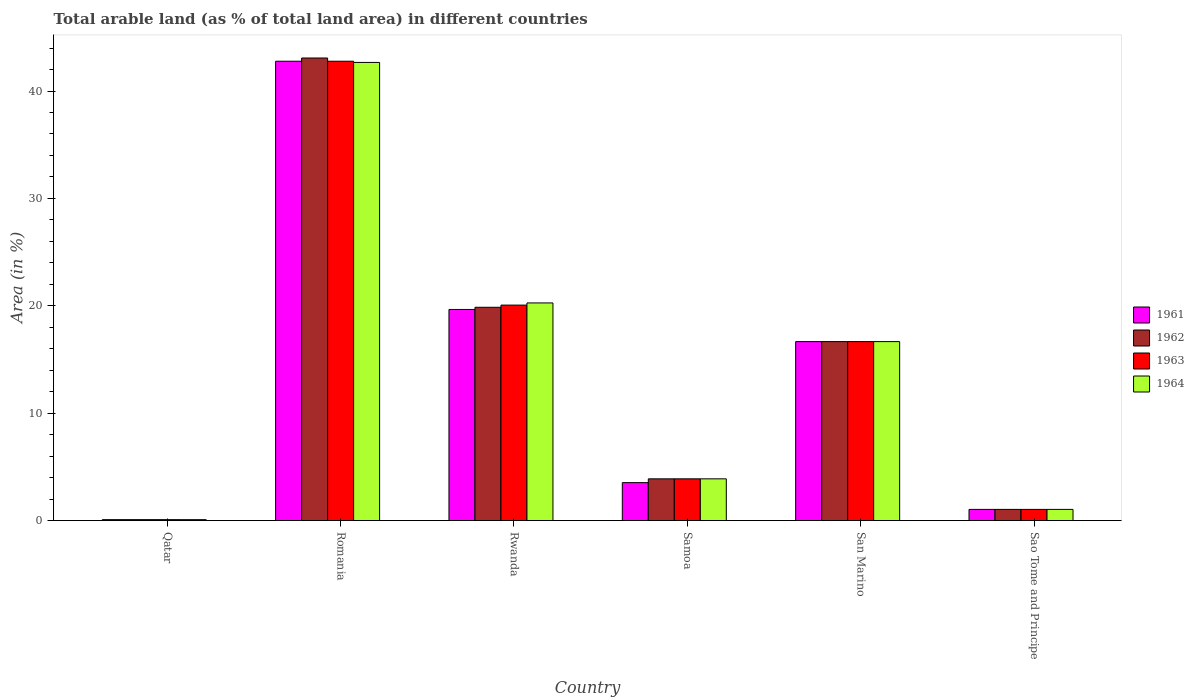How many different coloured bars are there?
Ensure brevity in your answer.  4. How many groups of bars are there?
Your response must be concise. 6. Are the number of bars per tick equal to the number of legend labels?
Make the answer very short. Yes. What is the label of the 2nd group of bars from the left?
Your response must be concise. Romania. In how many cases, is the number of bars for a given country not equal to the number of legend labels?
Make the answer very short. 0. What is the percentage of arable land in 1962 in Qatar?
Your answer should be very brief. 0.09. Across all countries, what is the maximum percentage of arable land in 1963?
Your response must be concise. 42.78. Across all countries, what is the minimum percentage of arable land in 1964?
Make the answer very short. 0.09. In which country was the percentage of arable land in 1963 maximum?
Provide a succinct answer. Romania. In which country was the percentage of arable land in 1964 minimum?
Keep it short and to the point. Qatar. What is the total percentage of arable land in 1961 in the graph?
Ensure brevity in your answer.  83.76. What is the difference between the percentage of arable land in 1962 in Qatar and that in Romania?
Ensure brevity in your answer.  -42.99. What is the difference between the percentage of arable land in 1962 in San Marino and the percentage of arable land in 1964 in Sao Tome and Principe?
Provide a short and direct response. 15.63. What is the average percentage of arable land in 1961 per country?
Give a very brief answer. 13.96. What is the difference between the percentage of arable land of/in 1964 and percentage of arable land of/in 1963 in Romania?
Keep it short and to the point. -0.11. What is the ratio of the percentage of arable land in 1963 in Rwanda to that in San Marino?
Provide a short and direct response. 1.2. Is the percentage of arable land in 1963 in Qatar less than that in Samoa?
Your answer should be compact. Yes. Is the difference between the percentage of arable land in 1964 in San Marino and Sao Tome and Principe greater than the difference between the percentage of arable land in 1963 in San Marino and Sao Tome and Principe?
Your response must be concise. No. What is the difference between the highest and the second highest percentage of arable land in 1961?
Your response must be concise. -26.11. What is the difference between the highest and the lowest percentage of arable land in 1964?
Offer a terse response. 42.58. Is the sum of the percentage of arable land in 1961 in Rwanda and San Marino greater than the maximum percentage of arable land in 1964 across all countries?
Give a very brief answer. No. What does the 1st bar from the left in Romania represents?
Provide a short and direct response. 1961. What does the 4th bar from the right in Qatar represents?
Offer a terse response. 1961. How many bars are there?
Your response must be concise. 24. How many countries are there in the graph?
Give a very brief answer. 6. Where does the legend appear in the graph?
Your response must be concise. Center right. How are the legend labels stacked?
Your response must be concise. Vertical. What is the title of the graph?
Offer a very short reply. Total arable land (as % of total land area) in different countries. Does "1981" appear as one of the legend labels in the graph?
Your answer should be compact. No. What is the label or title of the Y-axis?
Ensure brevity in your answer.  Area (in %). What is the Area (in %) of 1961 in Qatar?
Your response must be concise. 0.09. What is the Area (in %) of 1962 in Qatar?
Provide a short and direct response. 0.09. What is the Area (in %) in 1963 in Qatar?
Ensure brevity in your answer.  0.09. What is the Area (in %) of 1964 in Qatar?
Provide a succinct answer. 0.09. What is the Area (in %) of 1961 in Romania?
Provide a succinct answer. 42.78. What is the Area (in %) in 1962 in Romania?
Your answer should be compact. 43.08. What is the Area (in %) in 1963 in Romania?
Make the answer very short. 42.78. What is the Area (in %) of 1964 in Romania?
Provide a succinct answer. 42.66. What is the Area (in %) in 1961 in Rwanda?
Offer a terse response. 19.66. What is the Area (in %) of 1962 in Rwanda?
Offer a terse response. 19.86. What is the Area (in %) in 1963 in Rwanda?
Offer a terse response. 20.06. What is the Area (in %) of 1964 in Rwanda?
Give a very brief answer. 20.27. What is the Area (in %) of 1961 in Samoa?
Your answer should be compact. 3.53. What is the Area (in %) of 1962 in Samoa?
Give a very brief answer. 3.89. What is the Area (in %) of 1963 in Samoa?
Give a very brief answer. 3.89. What is the Area (in %) of 1964 in Samoa?
Your answer should be very brief. 3.89. What is the Area (in %) of 1961 in San Marino?
Give a very brief answer. 16.67. What is the Area (in %) in 1962 in San Marino?
Your answer should be very brief. 16.67. What is the Area (in %) of 1963 in San Marino?
Make the answer very short. 16.67. What is the Area (in %) of 1964 in San Marino?
Ensure brevity in your answer.  16.67. What is the Area (in %) of 1961 in Sao Tome and Principe?
Provide a succinct answer. 1.04. What is the Area (in %) of 1962 in Sao Tome and Principe?
Keep it short and to the point. 1.04. What is the Area (in %) of 1963 in Sao Tome and Principe?
Give a very brief answer. 1.04. What is the Area (in %) of 1964 in Sao Tome and Principe?
Your answer should be compact. 1.04. Across all countries, what is the maximum Area (in %) in 1961?
Ensure brevity in your answer.  42.78. Across all countries, what is the maximum Area (in %) of 1962?
Your response must be concise. 43.08. Across all countries, what is the maximum Area (in %) in 1963?
Make the answer very short. 42.78. Across all countries, what is the maximum Area (in %) in 1964?
Your answer should be compact. 42.66. Across all countries, what is the minimum Area (in %) of 1961?
Give a very brief answer. 0.09. Across all countries, what is the minimum Area (in %) of 1962?
Keep it short and to the point. 0.09. Across all countries, what is the minimum Area (in %) of 1963?
Your answer should be compact. 0.09. Across all countries, what is the minimum Area (in %) in 1964?
Provide a short and direct response. 0.09. What is the total Area (in %) in 1961 in the graph?
Your response must be concise. 83.76. What is the total Area (in %) in 1962 in the graph?
Offer a terse response. 84.62. What is the total Area (in %) in 1963 in the graph?
Your response must be concise. 84.52. What is the total Area (in %) of 1964 in the graph?
Provide a succinct answer. 84.61. What is the difference between the Area (in %) of 1961 in Qatar and that in Romania?
Your answer should be compact. -42.69. What is the difference between the Area (in %) of 1962 in Qatar and that in Romania?
Provide a short and direct response. -42.99. What is the difference between the Area (in %) of 1963 in Qatar and that in Romania?
Your response must be concise. -42.69. What is the difference between the Area (in %) in 1964 in Qatar and that in Romania?
Make the answer very short. -42.58. What is the difference between the Area (in %) of 1961 in Qatar and that in Rwanda?
Give a very brief answer. -19.57. What is the difference between the Area (in %) of 1962 in Qatar and that in Rwanda?
Provide a succinct answer. -19.78. What is the difference between the Area (in %) of 1963 in Qatar and that in Rwanda?
Offer a terse response. -19.98. What is the difference between the Area (in %) of 1964 in Qatar and that in Rwanda?
Offer a very short reply. -20.18. What is the difference between the Area (in %) in 1961 in Qatar and that in Samoa?
Ensure brevity in your answer.  -3.45. What is the difference between the Area (in %) of 1962 in Qatar and that in Samoa?
Your response must be concise. -3.8. What is the difference between the Area (in %) in 1963 in Qatar and that in Samoa?
Offer a very short reply. -3.8. What is the difference between the Area (in %) of 1964 in Qatar and that in Samoa?
Provide a short and direct response. -3.8. What is the difference between the Area (in %) of 1961 in Qatar and that in San Marino?
Make the answer very short. -16.58. What is the difference between the Area (in %) in 1962 in Qatar and that in San Marino?
Your answer should be compact. -16.58. What is the difference between the Area (in %) in 1963 in Qatar and that in San Marino?
Make the answer very short. -16.58. What is the difference between the Area (in %) of 1964 in Qatar and that in San Marino?
Give a very brief answer. -16.58. What is the difference between the Area (in %) of 1961 in Qatar and that in Sao Tome and Principe?
Make the answer very short. -0.96. What is the difference between the Area (in %) in 1962 in Qatar and that in Sao Tome and Principe?
Ensure brevity in your answer.  -0.96. What is the difference between the Area (in %) of 1963 in Qatar and that in Sao Tome and Principe?
Keep it short and to the point. -0.96. What is the difference between the Area (in %) of 1964 in Qatar and that in Sao Tome and Principe?
Your answer should be very brief. -0.96. What is the difference between the Area (in %) in 1961 in Romania and that in Rwanda?
Keep it short and to the point. 23.12. What is the difference between the Area (in %) in 1962 in Romania and that in Rwanda?
Your answer should be compact. 23.21. What is the difference between the Area (in %) of 1963 in Romania and that in Rwanda?
Offer a very short reply. 22.71. What is the difference between the Area (in %) in 1964 in Romania and that in Rwanda?
Keep it short and to the point. 22.4. What is the difference between the Area (in %) in 1961 in Romania and that in Samoa?
Your response must be concise. 39.24. What is the difference between the Area (in %) in 1962 in Romania and that in Samoa?
Ensure brevity in your answer.  39.19. What is the difference between the Area (in %) of 1963 in Romania and that in Samoa?
Offer a terse response. 38.89. What is the difference between the Area (in %) in 1964 in Romania and that in Samoa?
Offer a terse response. 38.78. What is the difference between the Area (in %) of 1961 in Romania and that in San Marino?
Your response must be concise. 26.11. What is the difference between the Area (in %) of 1962 in Romania and that in San Marino?
Your response must be concise. 26.41. What is the difference between the Area (in %) of 1963 in Romania and that in San Marino?
Give a very brief answer. 26.11. What is the difference between the Area (in %) of 1964 in Romania and that in San Marino?
Give a very brief answer. 26. What is the difference between the Area (in %) of 1961 in Romania and that in Sao Tome and Principe?
Offer a terse response. 41.73. What is the difference between the Area (in %) of 1962 in Romania and that in Sao Tome and Principe?
Give a very brief answer. 42.03. What is the difference between the Area (in %) of 1963 in Romania and that in Sao Tome and Principe?
Offer a terse response. 41.73. What is the difference between the Area (in %) in 1964 in Romania and that in Sao Tome and Principe?
Your response must be concise. 41.62. What is the difference between the Area (in %) in 1961 in Rwanda and that in Samoa?
Offer a very short reply. 16.13. What is the difference between the Area (in %) in 1962 in Rwanda and that in Samoa?
Give a very brief answer. 15.98. What is the difference between the Area (in %) in 1963 in Rwanda and that in Samoa?
Your answer should be very brief. 16.18. What is the difference between the Area (in %) in 1964 in Rwanda and that in Samoa?
Ensure brevity in your answer.  16.38. What is the difference between the Area (in %) of 1961 in Rwanda and that in San Marino?
Your answer should be very brief. 2.99. What is the difference between the Area (in %) in 1962 in Rwanda and that in San Marino?
Give a very brief answer. 3.2. What is the difference between the Area (in %) of 1963 in Rwanda and that in San Marino?
Provide a short and direct response. 3.4. What is the difference between the Area (in %) of 1964 in Rwanda and that in San Marino?
Your answer should be compact. 3.6. What is the difference between the Area (in %) in 1961 in Rwanda and that in Sao Tome and Principe?
Make the answer very short. 18.62. What is the difference between the Area (in %) in 1962 in Rwanda and that in Sao Tome and Principe?
Ensure brevity in your answer.  18.82. What is the difference between the Area (in %) in 1963 in Rwanda and that in Sao Tome and Principe?
Offer a terse response. 19.02. What is the difference between the Area (in %) in 1964 in Rwanda and that in Sao Tome and Principe?
Ensure brevity in your answer.  19.23. What is the difference between the Area (in %) in 1961 in Samoa and that in San Marino?
Your answer should be very brief. -13.13. What is the difference between the Area (in %) of 1962 in Samoa and that in San Marino?
Your answer should be compact. -12.78. What is the difference between the Area (in %) of 1963 in Samoa and that in San Marino?
Give a very brief answer. -12.78. What is the difference between the Area (in %) in 1964 in Samoa and that in San Marino?
Give a very brief answer. -12.78. What is the difference between the Area (in %) in 1961 in Samoa and that in Sao Tome and Principe?
Provide a short and direct response. 2.49. What is the difference between the Area (in %) in 1962 in Samoa and that in Sao Tome and Principe?
Keep it short and to the point. 2.85. What is the difference between the Area (in %) of 1963 in Samoa and that in Sao Tome and Principe?
Your answer should be very brief. 2.85. What is the difference between the Area (in %) of 1964 in Samoa and that in Sao Tome and Principe?
Offer a very short reply. 2.85. What is the difference between the Area (in %) in 1961 in San Marino and that in Sao Tome and Principe?
Provide a succinct answer. 15.62. What is the difference between the Area (in %) in 1962 in San Marino and that in Sao Tome and Principe?
Keep it short and to the point. 15.62. What is the difference between the Area (in %) of 1963 in San Marino and that in Sao Tome and Principe?
Your answer should be compact. 15.62. What is the difference between the Area (in %) in 1964 in San Marino and that in Sao Tome and Principe?
Your response must be concise. 15.62. What is the difference between the Area (in %) of 1961 in Qatar and the Area (in %) of 1962 in Romania?
Give a very brief answer. -42.99. What is the difference between the Area (in %) in 1961 in Qatar and the Area (in %) in 1963 in Romania?
Give a very brief answer. -42.69. What is the difference between the Area (in %) in 1961 in Qatar and the Area (in %) in 1964 in Romania?
Offer a terse response. -42.58. What is the difference between the Area (in %) of 1962 in Qatar and the Area (in %) of 1963 in Romania?
Offer a very short reply. -42.69. What is the difference between the Area (in %) in 1962 in Qatar and the Area (in %) in 1964 in Romania?
Ensure brevity in your answer.  -42.58. What is the difference between the Area (in %) of 1963 in Qatar and the Area (in %) of 1964 in Romania?
Keep it short and to the point. -42.58. What is the difference between the Area (in %) in 1961 in Qatar and the Area (in %) in 1962 in Rwanda?
Your response must be concise. -19.78. What is the difference between the Area (in %) in 1961 in Qatar and the Area (in %) in 1963 in Rwanda?
Make the answer very short. -19.98. What is the difference between the Area (in %) in 1961 in Qatar and the Area (in %) in 1964 in Rwanda?
Make the answer very short. -20.18. What is the difference between the Area (in %) of 1962 in Qatar and the Area (in %) of 1963 in Rwanda?
Provide a short and direct response. -19.98. What is the difference between the Area (in %) of 1962 in Qatar and the Area (in %) of 1964 in Rwanda?
Keep it short and to the point. -20.18. What is the difference between the Area (in %) of 1963 in Qatar and the Area (in %) of 1964 in Rwanda?
Your answer should be compact. -20.18. What is the difference between the Area (in %) of 1961 in Qatar and the Area (in %) of 1962 in Samoa?
Provide a succinct answer. -3.8. What is the difference between the Area (in %) in 1961 in Qatar and the Area (in %) in 1963 in Samoa?
Your answer should be very brief. -3.8. What is the difference between the Area (in %) of 1961 in Qatar and the Area (in %) of 1964 in Samoa?
Your answer should be very brief. -3.8. What is the difference between the Area (in %) of 1962 in Qatar and the Area (in %) of 1963 in Samoa?
Give a very brief answer. -3.8. What is the difference between the Area (in %) of 1962 in Qatar and the Area (in %) of 1964 in Samoa?
Offer a very short reply. -3.8. What is the difference between the Area (in %) in 1963 in Qatar and the Area (in %) in 1964 in Samoa?
Make the answer very short. -3.8. What is the difference between the Area (in %) of 1961 in Qatar and the Area (in %) of 1962 in San Marino?
Ensure brevity in your answer.  -16.58. What is the difference between the Area (in %) of 1961 in Qatar and the Area (in %) of 1963 in San Marino?
Your answer should be very brief. -16.58. What is the difference between the Area (in %) of 1961 in Qatar and the Area (in %) of 1964 in San Marino?
Offer a very short reply. -16.58. What is the difference between the Area (in %) in 1962 in Qatar and the Area (in %) in 1963 in San Marino?
Give a very brief answer. -16.58. What is the difference between the Area (in %) of 1962 in Qatar and the Area (in %) of 1964 in San Marino?
Your response must be concise. -16.58. What is the difference between the Area (in %) of 1963 in Qatar and the Area (in %) of 1964 in San Marino?
Ensure brevity in your answer.  -16.58. What is the difference between the Area (in %) of 1961 in Qatar and the Area (in %) of 1962 in Sao Tome and Principe?
Provide a succinct answer. -0.96. What is the difference between the Area (in %) in 1961 in Qatar and the Area (in %) in 1963 in Sao Tome and Principe?
Keep it short and to the point. -0.96. What is the difference between the Area (in %) of 1961 in Qatar and the Area (in %) of 1964 in Sao Tome and Principe?
Provide a short and direct response. -0.96. What is the difference between the Area (in %) in 1962 in Qatar and the Area (in %) in 1963 in Sao Tome and Principe?
Provide a succinct answer. -0.96. What is the difference between the Area (in %) in 1962 in Qatar and the Area (in %) in 1964 in Sao Tome and Principe?
Your answer should be compact. -0.96. What is the difference between the Area (in %) in 1963 in Qatar and the Area (in %) in 1964 in Sao Tome and Principe?
Offer a terse response. -0.96. What is the difference between the Area (in %) in 1961 in Romania and the Area (in %) in 1962 in Rwanda?
Keep it short and to the point. 22.91. What is the difference between the Area (in %) in 1961 in Romania and the Area (in %) in 1963 in Rwanda?
Give a very brief answer. 22.71. What is the difference between the Area (in %) of 1961 in Romania and the Area (in %) of 1964 in Rwanda?
Offer a terse response. 22.51. What is the difference between the Area (in %) of 1962 in Romania and the Area (in %) of 1963 in Rwanda?
Your answer should be compact. 23.01. What is the difference between the Area (in %) of 1962 in Romania and the Area (in %) of 1964 in Rwanda?
Provide a short and direct response. 22.81. What is the difference between the Area (in %) in 1963 in Romania and the Area (in %) in 1964 in Rwanda?
Provide a short and direct response. 22.51. What is the difference between the Area (in %) of 1961 in Romania and the Area (in %) of 1962 in Samoa?
Ensure brevity in your answer.  38.89. What is the difference between the Area (in %) of 1961 in Romania and the Area (in %) of 1963 in Samoa?
Ensure brevity in your answer.  38.89. What is the difference between the Area (in %) of 1961 in Romania and the Area (in %) of 1964 in Samoa?
Your response must be concise. 38.89. What is the difference between the Area (in %) of 1962 in Romania and the Area (in %) of 1963 in Samoa?
Make the answer very short. 39.19. What is the difference between the Area (in %) in 1962 in Romania and the Area (in %) in 1964 in Samoa?
Your answer should be compact. 39.19. What is the difference between the Area (in %) of 1963 in Romania and the Area (in %) of 1964 in Samoa?
Your response must be concise. 38.89. What is the difference between the Area (in %) of 1961 in Romania and the Area (in %) of 1962 in San Marino?
Your answer should be compact. 26.11. What is the difference between the Area (in %) of 1961 in Romania and the Area (in %) of 1963 in San Marino?
Ensure brevity in your answer.  26.11. What is the difference between the Area (in %) of 1961 in Romania and the Area (in %) of 1964 in San Marino?
Your response must be concise. 26.11. What is the difference between the Area (in %) in 1962 in Romania and the Area (in %) in 1963 in San Marino?
Give a very brief answer. 26.41. What is the difference between the Area (in %) in 1962 in Romania and the Area (in %) in 1964 in San Marino?
Make the answer very short. 26.41. What is the difference between the Area (in %) in 1963 in Romania and the Area (in %) in 1964 in San Marino?
Offer a very short reply. 26.11. What is the difference between the Area (in %) of 1961 in Romania and the Area (in %) of 1962 in Sao Tome and Principe?
Make the answer very short. 41.73. What is the difference between the Area (in %) of 1961 in Romania and the Area (in %) of 1963 in Sao Tome and Principe?
Make the answer very short. 41.73. What is the difference between the Area (in %) in 1961 in Romania and the Area (in %) in 1964 in Sao Tome and Principe?
Provide a short and direct response. 41.73. What is the difference between the Area (in %) in 1962 in Romania and the Area (in %) in 1963 in Sao Tome and Principe?
Keep it short and to the point. 42.03. What is the difference between the Area (in %) of 1962 in Romania and the Area (in %) of 1964 in Sao Tome and Principe?
Ensure brevity in your answer.  42.03. What is the difference between the Area (in %) of 1963 in Romania and the Area (in %) of 1964 in Sao Tome and Principe?
Offer a terse response. 41.73. What is the difference between the Area (in %) of 1961 in Rwanda and the Area (in %) of 1962 in Samoa?
Your answer should be compact. 15.77. What is the difference between the Area (in %) in 1961 in Rwanda and the Area (in %) in 1963 in Samoa?
Offer a very short reply. 15.77. What is the difference between the Area (in %) of 1961 in Rwanda and the Area (in %) of 1964 in Samoa?
Offer a terse response. 15.77. What is the difference between the Area (in %) in 1962 in Rwanda and the Area (in %) in 1963 in Samoa?
Keep it short and to the point. 15.98. What is the difference between the Area (in %) in 1962 in Rwanda and the Area (in %) in 1964 in Samoa?
Your response must be concise. 15.98. What is the difference between the Area (in %) of 1963 in Rwanda and the Area (in %) of 1964 in Samoa?
Give a very brief answer. 16.18. What is the difference between the Area (in %) of 1961 in Rwanda and the Area (in %) of 1962 in San Marino?
Your answer should be compact. 2.99. What is the difference between the Area (in %) in 1961 in Rwanda and the Area (in %) in 1963 in San Marino?
Provide a short and direct response. 2.99. What is the difference between the Area (in %) of 1961 in Rwanda and the Area (in %) of 1964 in San Marino?
Your answer should be very brief. 2.99. What is the difference between the Area (in %) of 1962 in Rwanda and the Area (in %) of 1963 in San Marino?
Ensure brevity in your answer.  3.2. What is the difference between the Area (in %) of 1962 in Rwanda and the Area (in %) of 1964 in San Marino?
Make the answer very short. 3.2. What is the difference between the Area (in %) in 1963 in Rwanda and the Area (in %) in 1964 in San Marino?
Your response must be concise. 3.4. What is the difference between the Area (in %) of 1961 in Rwanda and the Area (in %) of 1962 in Sao Tome and Principe?
Keep it short and to the point. 18.62. What is the difference between the Area (in %) in 1961 in Rwanda and the Area (in %) in 1963 in Sao Tome and Principe?
Make the answer very short. 18.62. What is the difference between the Area (in %) of 1961 in Rwanda and the Area (in %) of 1964 in Sao Tome and Principe?
Your response must be concise. 18.62. What is the difference between the Area (in %) in 1962 in Rwanda and the Area (in %) in 1963 in Sao Tome and Principe?
Provide a short and direct response. 18.82. What is the difference between the Area (in %) in 1962 in Rwanda and the Area (in %) in 1964 in Sao Tome and Principe?
Offer a terse response. 18.82. What is the difference between the Area (in %) of 1963 in Rwanda and the Area (in %) of 1964 in Sao Tome and Principe?
Ensure brevity in your answer.  19.02. What is the difference between the Area (in %) in 1961 in Samoa and the Area (in %) in 1962 in San Marino?
Provide a succinct answer. -13.13. What is the difference between the Area (in %) in 1961 in Samoa and the Area (in %) in 1963 in San Marino?
Provide a short and direct response. -13.13. What is the difference between the Area (in %) of 1961 in Samoa and the Area (in %) of 1964 in San Marino?
Provide a succinct answer. -13.13. What is the difference between the Area (in %) of 1962 in Samoa and the Area (in %) of 1963 in San Marino?
Ensure brevity in your answer.  -12.78. What is the difference between the Area (in %) in 1962 in Samoa and the Area (in %) in 1964 in San Marino?
Provide a succinct answer. -12.78. What is the difference between the Area (in %) in 1963 in Samoa and the Area (in %) in 1964 in San Marino?
Give a very brief answer. -12.78. What is the difference between the Area (in %) of 1961 in Samoa and the Area (in %) of 1962 in Sao Tome and Principe?
Provide a succinct answer. 2.49. What is the difference between the Area (in %) in 1961 in Samoa and the Area (in %) in 1963 in Sao Tome and Principe?
Offer a very short reply. 2.49. What is the difference between the Area (in %) in 1961 in Samoa and the Area (in %) in 1964 in Sao Tome and Principe?
Offer a terse response. 2.49. What is the difference between the Area (in %) in 1962 in Samoa and the Area (in %) in 1963 in Sao Tome and Principe?
Provide a succinct answer. 2.85. What is the difference between the Area (in %) of 1962 in Samoa and the Area (in %) of 1964 in Sao Tome and Principe?
Offer a terse response. 2.85. What is the difference between the Area (in %) of 1963 in Samoa and the Area (in %) of 1964 in Sao Tome and Principe?
Offer a very short reply. 2.85. What is the difference between the Area (in %) in 1961 in San Marino and the Area (in %) in 1962 in Sao Tome and Principe?
Provide a short and direct response. 15.62. What is the difference between the Area (in %) in 1961 in San Marino and the Area (in %) in 1963 in Sao Tome and Principe?
Your response must be concise. 15.62. What is the difference between the Area (in %) in 1961 in San Marino and the Area (in %) in 1964 in Sao Tome and Principe?
Give a very brief answer. 15.62. What is the difference between the Area (in %) of 1962 in San Marino and the Area (in %) of 1963 in Sao Tome and Principe?
Keep it short and to the point. 15.62. What is the difference between the Area (in %) in 1962 in San Marino and the Area (in %) in 1964 in Sao Tome and Principe?
Offer a terse response. 15.62. What is the difference between the Area (in %) of 1963 in San Marino and the Area (in %) of 1964 in Sao Tome and Principe?
Offer a terse response. 15.62. What is the average Area (in %) in 1961 per country?
Your answer should be very brief. 13.96. What is the average Area (in %) in 1962 per country?
Offer a very short reply. 14.1. What is the average Area (in %) of 1963 per country?
Offer a terse response. 14.09. What is the average Area (in %) in 1964 per country?
Ensure brevity in your answer.  14.1. What is the difference between the Area (in %) of 1961 and Area (in %) of 1964 in Qatar?
Your answer should be compact. 0. What is the difference between the Area (in %) in 1962 and Area (in %) in 1964 in Qatar?
Your answer should be very brief. 0. What is the difference between the Area (in %) in 1961 and Area (in %) in 1962 in Romania?
Your answer should be very brief. -0.3. What is the difference between the Area (in %) in 1961 and Area (in %) in 1964 in Romania?
Your response must be concise. 0.11. What is the difference between the Area (in %) of 1962 and Area (in %) of 1963 in Romania?
Offer a very short reply. 0.3. What is the difference between the Area (in %) of 1962 and Area (in %) of 1964 in Romania?
Make the answer very short. 0.41. What is the difference between the Area (in %) of 1963 and Area (in %) of 1964 in Romania?
Your answer should be compact. 0.11. What is the difference between the Area (in %) in 1961 and Area (in %) in 1962 in Rwanda?
Offer a terse response. -0.2. What is the difference between the Area (in %) of 1961 and Area (in %) of 1963 in Rwanda?
Give a very brief answer. -0.41. What is the difference between the Area (in %) in 1961 and Area (in %) in 1964 in Rwanda?
Your answer should be very brief. -0.61. What is the difference between the Area (in %) in 1962 and Area (in %) in 1963 in Rwanda?
Your answer should be compact. -0.2. What is the difference between the Area (in %) of 1962 and Area (in %) of 1964 in Rwanda?
Ensure brevity in your answer.  -0.41. What is the difference between the Area (in %) of 1963 and Area (in %) of 1964 in Rwanda?
Provide a succinct answer. -0.2. What is the difference between the Area (in %) in 1961 and Area (in %) in 1962 in Samoa?
Your response must be concise. -0.35. What is the difference between the Area (in %) in 1961 and Area (in %) in 1963 in Samoa?
Offer a terse response. -0.35. What is the difference between the Area (in %) of 1961 and Area (in %) of 1964 in Samoa?
Your answer should be compact. -0.35. What is the difference between the Area (in %) in 1962 and Area (in %) in 1964 in Samoa?
Provide a succinct answer. 0. What is the difference between the Area (in %) in 1961 and Area (in %) in 1962 in San Marino?
Offer a terse response. 0. What is the difference between the Area (in %) of 1962 and Area (in %) of 1963 in San Marino?
Provide a succinct answer. 0. What is the difference between the Area (in %) of 1962 and Area (in %) of 1964 in San Marino?
Give a very brief answer. 0. What is the difference between the Area (in %) of 1961 and Area (in %) of 1962 in Sao Tome and Principe?
Ensure brevity in your answer.  0. What is the difference between the Area (in %) in 1961 and Area (in %) in 1963 in Sao Tome and Principe?
Offer a very short reply. 0. What is the difference between the Area (in %) of 1963 and Area (in %) of 1964 in Sao Tome and Principe?
Offer a very short reply. 0. What is the ratio of the Area (in %) in 1961 in Qatar to that in Romania?
Your answer should be very brief. 0. What is the ratio of the Area (in %) of 1962 in Qatar to that in Romania?
Give a very brief answer. 0. What is the ratio of the Area (in %) of 1963 in Qatar to that in Romania?
Your response must be concise. 0. What is the ratio of the Area (in %) of 1964 in Qatar to that in Romania?
Your response must be concise. 0. What is the ratio of the Area (in %) in 1961 in Qatar to that in Rwanda?
Provide a succinct answer. 0. What is the ratio of the Area (in %) of 1962 in Qatar to that in Rwanda?
Offer a terse response. 0. What is the ratio of the Area (in %) in 1963 in Qatar to that in Rwanda?
Your response must be concise. 0. What is the ratio of the Area (in %) in 1964 in Qatar to that in Rwanda?
Provide a short and direct response. 0. What is the ratio of the Area (in %) in 1961 in Qatar to that in Samoa?
Provide a short and direct response. 0.02. What is the ratio of the Area (in %) in 1962 in Qatar to that in Samoa?
Provide a short and direct response. 0.02. What is the ratio of the Area (in %) of 1963 in Qatar to that in Samoa?
Ensure brevity in your answer.  0.02. What is the ratio of the Area (in %) in 1964 in Qatar to that in Samoa?
Offer a terse response. 0.02. What is the ratio of the Area (in %) in 1961 in Qatar to that in San Marino?
Your answer should be very brief. 0.01. What is the ratio of the Area (in %) of 1962 in Qatar to that in San Marino?
Your answer should be very brief. 0.01. What is the ratio of the Area (in %) in 1963 in Qatar to that in San Marino?
Ensure brevity in your answer.  0.01. What is the ratio of the Area (in %) of 1964 in Qatar to that in San Marino?
Provide a short and direct response. 0.01. What is the ratio of the Area (in %) of 1961 in Qatar to that in Sao Tome and Principe?
Provide a short and direct response. 0.08. What is the ratio of the Area (in %) of 1962 in Qatar to that in Sao Tome and Principe?
Keep it short and to the point. 0.08. What is the ratio of the Area (in %) of 1963 in Qatar to that in Sao Tome and Principe?
Offer a very short reply. 0.08. What is the ratio of the Area (in %) in 1964 in Qatar to that in Sao Tome and Principe?
Keep it short and to the point. 0.08. What is the ratio of the Area (in %) in 1961 in Romania to that in Rwanda?
Ensure brevity in your answer.  2.18. What is the ratio of the Area (in %) in 1962 in Romania to that in Rwanda?
Give a very brief answer. 2.17. What is the ratio of the Area (in %) in 1963 in Romania to that in Rwanda?
Give a very brief answer. 2.13. What is the ratio of the Area (in %) in 1964 in Romania to that in Rwanda?
Ensure brevity in your answer.  2.1. What is the ratio of the Area (in %) of 1961 in Romania to that in Samoa?
Offer a very short reply. 12.11. What is the ratio of the Area (in %) of 1962 in Romania to that in Samoa?
Provide a succinct answer. 11.08. What is the ratio of the Area (in %) of 1963 in Romania to that in Samoa?
Offer a terse response. 11.01. What is the ratio of the Area (in %) in 1964 in Romania to that in Samoa?
Your answer should be compact. 10.98. What is the ratio of the Area (in %) in 1961 in Romania to that in San Marino?
Offer a terse response. 2.57. What is the ratio of the Area (in %) in 1962 in Romania to that in San Marino?
Make the answer very short. 2.58. What is the ratio of the Area (in %) of 1963 in Romania to that in San Marino?
Your answer should be very brief. 2.57. What is the ratio of the Area (in %) in 1964 in Romania to that in San Marino?
Keep it short and to the point. 2.56. What is the ratio of the Area (in %) in 1961 in Romania to that in Sao Tome and Principe?
Offer a terse response. 41.06. What is the ratio of the Area (in %) of 1962 in Romania to that in Sao Tome and Principe?
Make the answer very short. 41.35. What is the ratio of the Area (in %) in 1963 in Romania to that in Sao Tome and Principe?
Keep it short and to the point. 41.06. What is the ratio of the Area (in %) in 1964 in Romania to that in Sao Tome and Principe?
Provide a short and direct response. 40.96. What is the ratio of the Area (in %) of 1961 in Rwanda to that in Samoa?
Ensure brevity in your answer.  5.56. What is the ratio of the Area (in %) in 1962 in Rwanda to that in Samoa?
Offer a very short reply. 5.11. What is the ratio of the Area (in %) of 1963 in Rwanda to that in Samoa?
Provide a short and direct response. 5.16. What is the ratio of the Area (in %) in 1964 in Rwanda to that in Samoa?
Your answer should be very brief. 5.21. What is the ratio of the Area (in %) in 1961 in Rwanda to that in San Marino?
Keep it short and to the point. 1.18. What is the ratio of the Area (in %) of 1962 in Rwanda to that in San Marino?
Offer a terse response. 1.19. What is the ratio of the Area (in %) of 1963 in Rwanda to that in San Marino?
Your answer should be compact. 1.2. What is the ratio of the Area (in %) in 1964 in Rwanda to that in San Marino?
Your response must be concise. 1.22. What is the ratio of the Area (in %) in 1961 in Rwanda to that in Sao Tome and Principe?
Offer a terse response. 18.87. What is the ratio of the Area (in %) in 1962 in Rwanda to that in Sao Tome and Principe?
Ensure brevity in your answer.  19.07. What is the ratio of the Area (in %) in 1963 in Rwanda to that in Sao Tome and Principe?
Provide a short and direct response. 19.26. What is the ratio of the Area (in %) of 1964 in Rwanda to that in Sao Tome and Principe?
Offer a terse response. 19.46. What is the ratio of the Area (in %) in 1961 in Samoa to that in San Marino?
Your answer should be very brief. 0.21. What is the ratio of the Area (in %) in 1962 in Samoa to that in San Marino?
Provide a succinct answer. 0.23. What is the ratio of the Area (in %) in 1963 in Samoa to that in San Marino?
Give a very brief answer. 0.23. What is the ratio of the Area (in %) of 1964 in Samoa to that in San Marino?
Offer a very short reply. 0.23. What is the ratio of the Area (in %) of 1961 in Samoa to that in Sao Tome and Principe?
Provide a short and direct response. 3.39. What is the ratio of the Area (in %) in 1962 in Samoa to that in Sao Tome and Principe?
Give a very brief answer. 3.73. What is the ratio of the Area (in %) of 1963 in Samoa to that in Sao Tome and Principe?
Provide a short and direct response. 3.73. What is the ratio of the Area (in %) of 1964 in Samoa to that in Sao Tome and Principe?
Offer a terse response. 3.73. What is the ratio of the Area (in %) of 1961 in San Marino to that in Sao Tome and Principe?
Your answer should be compact. 16. What is the ratio of the Area (in %) of 1962 in San Marino to that in Sao Tome and Principe?
Provide a short and direct response. 16. What is the ratio of the Area (in %) in 1964 in San Marino to that in Sao Tome and Principe?
Ensure brevity in your answer.  16. What is the difference between the highest and the second highest Area (in %) in 1961?
Give a very brief answer. 23.12. What is the difference between the highest and the second highest Area (in %) of 1962?
Give a very brief answer. 23.21. What is the difference between the highest and the second highest Area (in %) in 1963?
Offer a terse response. 22.71. What is the difference between the highest and the second highest Area (in %) of 1964?
Ensure brevity in your answer.  22.4. What is the difference between the highest and the lowest Area (in %) in 1961?
Provide a short and direct response. 42.69. What is the difference between the highest and the lowest Area (in %) of 1962?
Make the answer very short. 42.99. What is the difference between the highest and the lowest Area (in %) of 1963?
Your response must be concise. 42.69. What is the difference between the highest and the lowest Area (in %) in 1964?
Your answer should be compact. 42.58. 